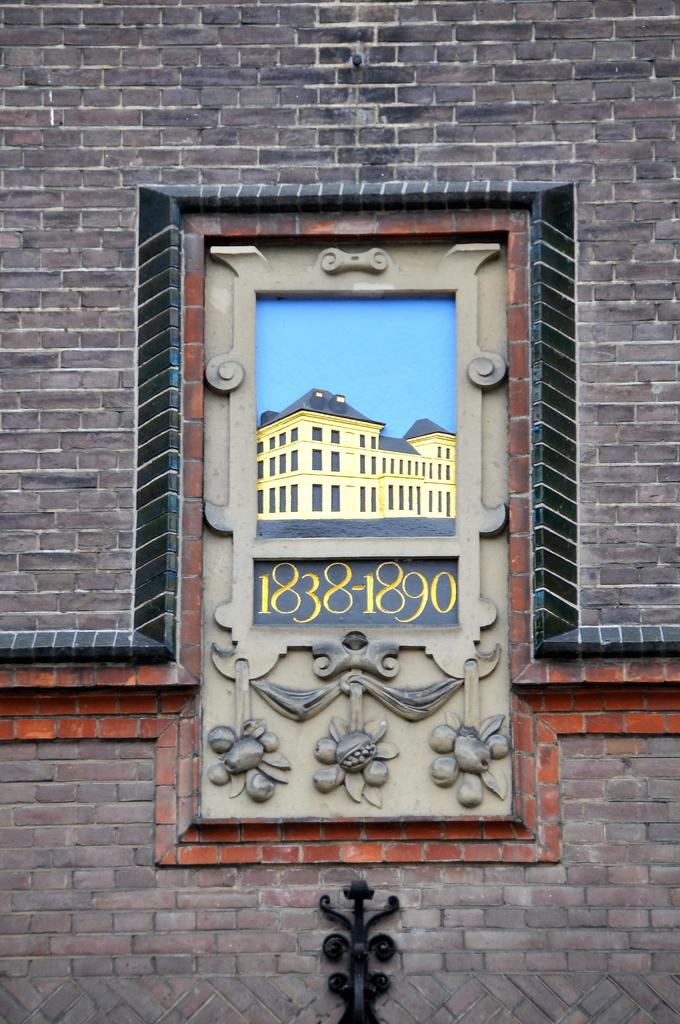What is the main object in the image? There is a board in the image. Where is the board located in relation to other objects or structures? The board is attached to the wall. What type of sail can be seen on the board in the image? There is no sail present on the board in the image. 